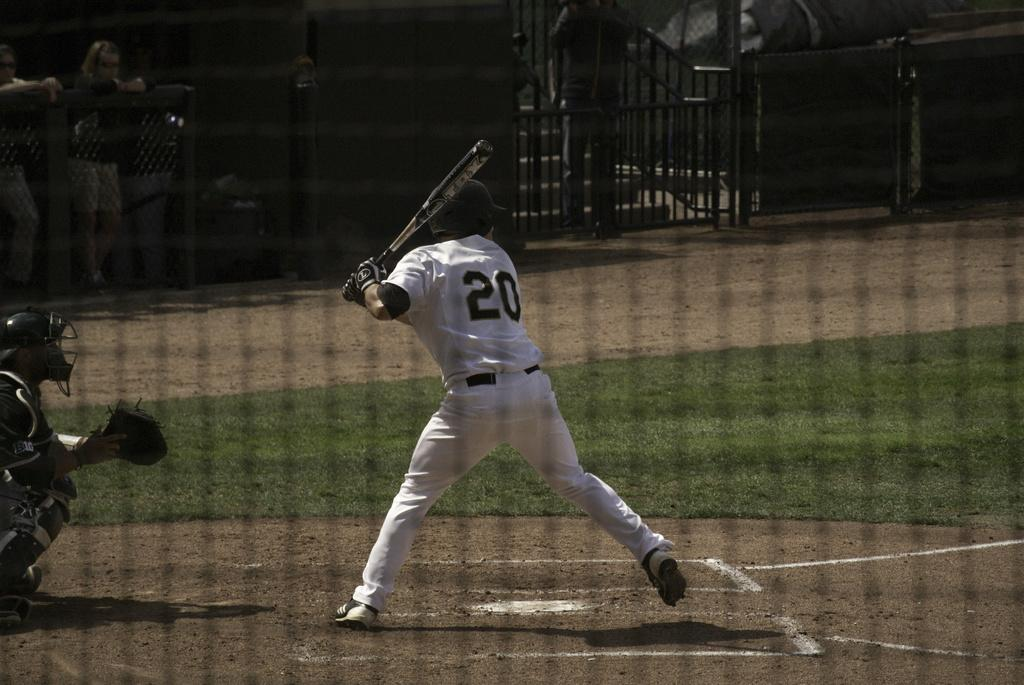<image>
Write a terse but informative summary of the picture. A batter getting ready to hit a ball and wearing number 20. 